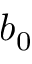Convert formula to latex. <formula><loc_0><loc_0><loc_500><loc_500>b _ { 0 }</formula> 